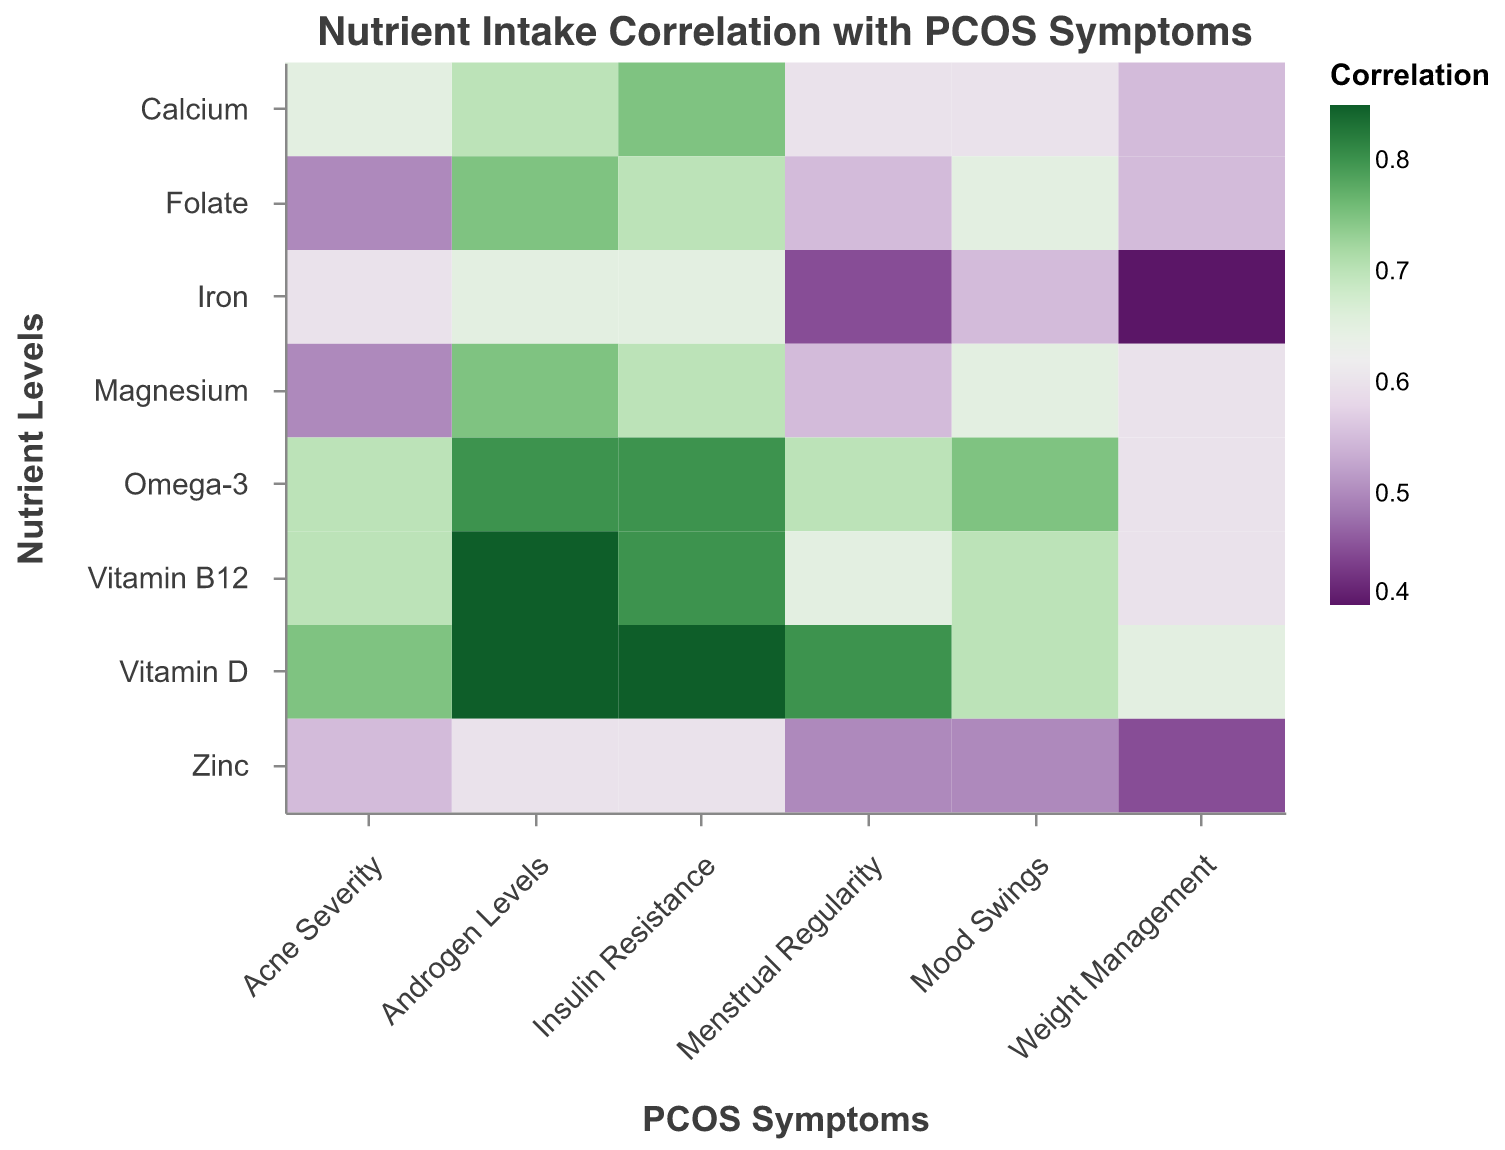What's the title of the Heatmap? The title of the heatmap is located at the top of the visual, usually in a larger and bolder font than other text elements in the figure.
Answer: Nutrient Intake Correlation with PCOS Symptoms What nutrient level shows the highest correlation with "Androgen Levels"? To determine this, examine the color intensity of the cells corresponding to "Androgen Levels" to find the highest correlation value. This value appears most intense (darkest) next to "Vitamin D" and "Vitamin B12".
Answer: Vitamin D and Vitamin B12 Which symptom has the least correlation with "Folate"? Look at the correlation values in the row for "Folate" and identify the lowest value. The lowest correlation value in this row corresponds to the "Acne Severity" symptom.
Answer: Acne Severity How does "Omega-3" intake correlate with "Mood Swings" compared to "Calcium" intake with the same symptom? To compare, find the correlation values of "Omega-3" and "Calcium" with "Mood Swings". Omega-3 correlates at 0.75, while Calcium correlates at 0.6.
Answer: Omega-3 has a higher correlation with Mood Swings compared to Calcium Which nutrients have a correlation over 0.8 with any symptoms? Scan through all the rows to find correlation values greater than 0.8. Vitamin D has correlations over 0.8 with "Androgen Levels," "Menstrual Regularity," and "Insulin Resistance." Omega-3 has a correlation over 0.8 with "Androgen Levels" and "Insulin Resistance." Vitamin B12 has correlations over 0.8 with "Androgen Levels" and "Insulin Resistance."
Answer: Vitamin D, Omega-3, and Vitamin B12 Between "Magnesium" and "Zinc," which nutrient intake correlates more strongly with "Weight Management"? Compare the correlation values of both "Magnesium" and "Zinc" in the "Weight Management" column. Magnesium has a correlation of 0.6, while Zinc has a correlation of 0.45 with "Weight Management."
Answer: Magnesium Given the data, what's the average correlation of "Iron" with all listed PCOS symptoms? To calculate the average, sum the correlation values for "Iron" and divide by the number of symptoms: (0.65 + 0.45 + 0.6 + 0.4 + 0.55 + 0.65)/6. The sum is 3.3, so the average is 3.3/6.
Answer: 0.55 Which nutrient level has the highest average correlation across all symptoms? Calculate the average correlation value for each nutrient level across all symptoms and compare them. Here, the values would need to be computed for each nutrient and checked. Vitamin D has quite high correlations.
Answer: Vitamin D What correlations exist between "Vitamin B12" and "Menstrual Regularity"? Find the intersection cell for "Vitamin B12" and "Menstrual Regularity" in the heatmap to see its correlation value.
Answer: 0.65 